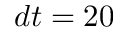<formula> <loc_0><loc_0><loc_500><loc_500>d t = 2 0</formula> 